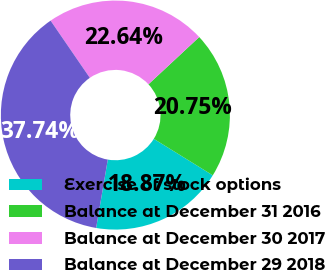Convert chart. <chart><loc_0><loc_0><loc_500><loc_500><pie_chart><fcel>Exercise of stock options<fcel>Balance at December 31 2016<fcel>Balance at December 30 2017<fcel>Balance at December 29 2018<nl><fcel>18.87%<fcel>20.75%<fcel>22.64%<fcel>37.74%<nl></chart> 